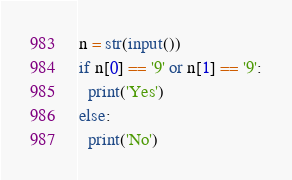<code> <loc_0><loc_0><loc_500><loc_500><_Python_>n = str(input())
if n[0] == '9' or n[1] == '9':
  print('Yes')
else:
  print('No')</code> 